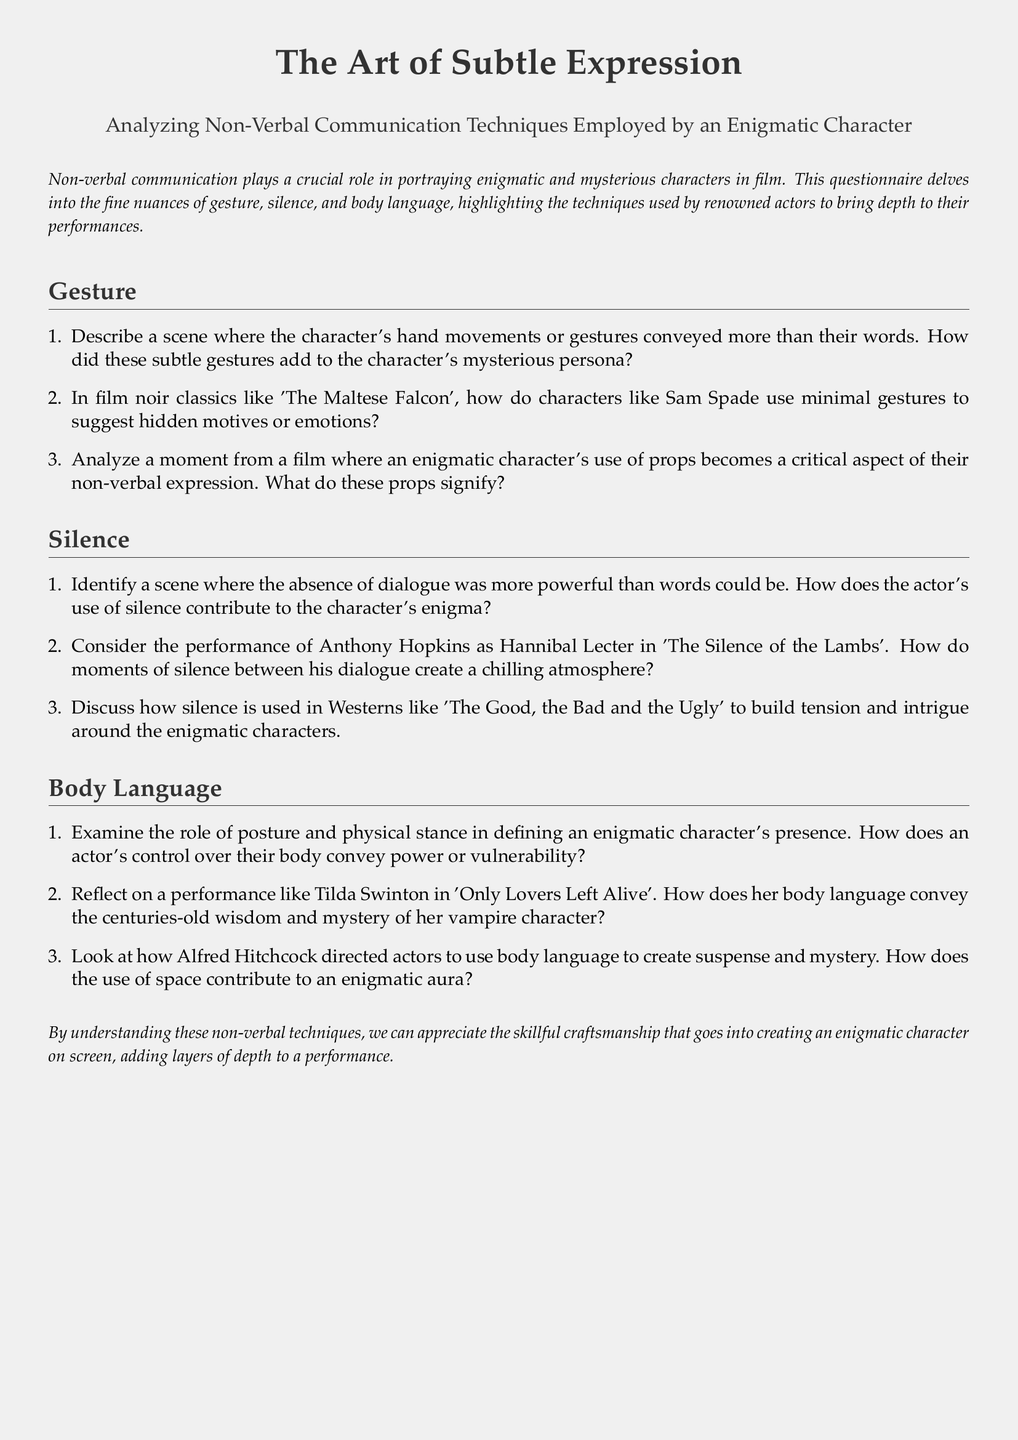What is the title of the document? The title is prominently displayed at the beginning of the document.
Answer: The Art of Subtle Expression Who is the author of the analyzed performance in 'The Silence of the Lambs'? The document references a renowned actor known for his portrayal of a specific character.
Answer: Anthony Hopkins In which film does Tilda Swinton portray her enigmatic character? The document mentions a specific film featuring Tilda Swinton.
Answer: Only Lovers Left Alive What is one of the non-verbal communication techniques discussed? The document lists techniques such as gesture, silence, and body language.
Answer: Gesture How does the character's hand movements impact their persona? This is addressed in the first question under the Gesture section.
Answer: Mysterious persona What type of communication is emphasized in the questionnaire? The introduction mentions the crucial role of a specific type of communication in film.
Answer: Non-verbal communication How does silence enhance the atmosphere in 'The Silence of the Lambs'? The reasoning involves understanding the impact of silence in the character's dialogue.
Answer: Chilling atmosphere What role does body language play in an enigmatic character's definition? This is outlined in the first question under the Body Language section.
Answer: Presence Which film genre is mentioned in relation to silence building tension? The document refers to a specific genre regarding its use of silence.
Answer: Westerns 